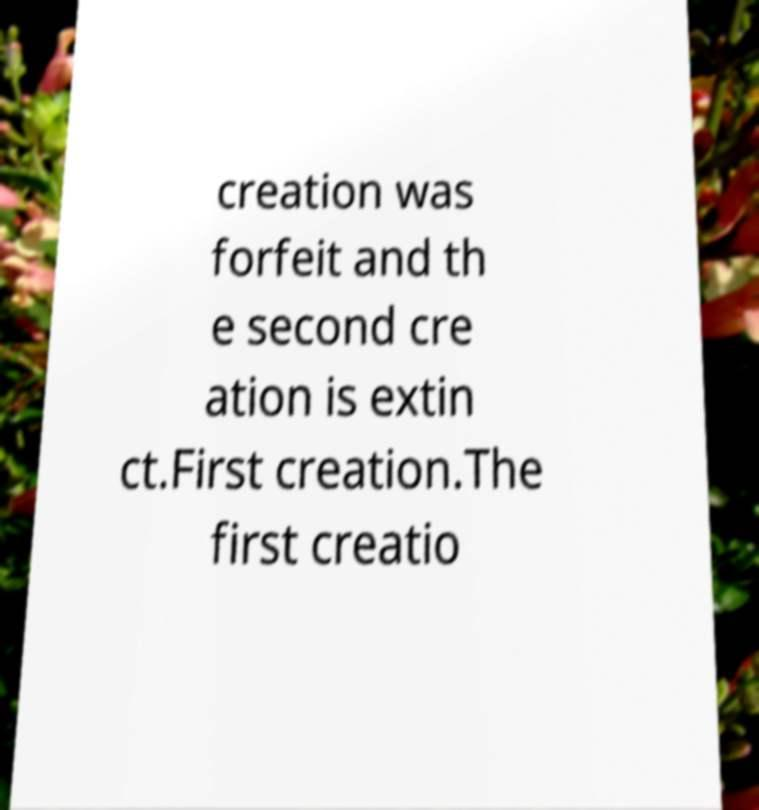Could you extract and type out the text from this image? creation was forfeit and th e second cre ation is extin ct.First creation.The first creatio 